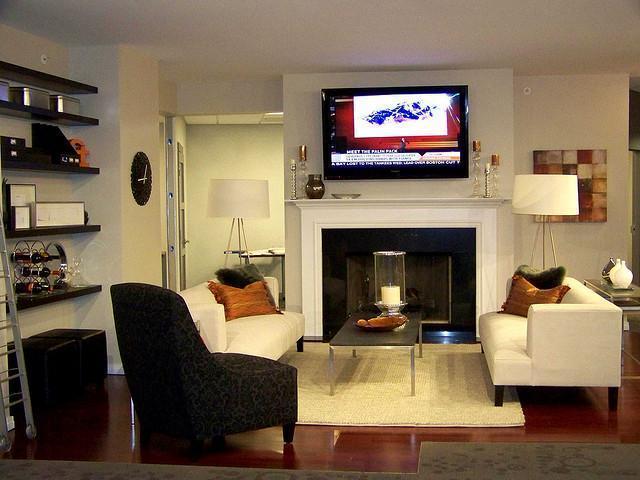How many pillows are pictured?
Give a very brief answer. 4. How many couches are there?
Give a very brief answer. 2. How many people are in the photo?
Give a very brief answer. 0. 